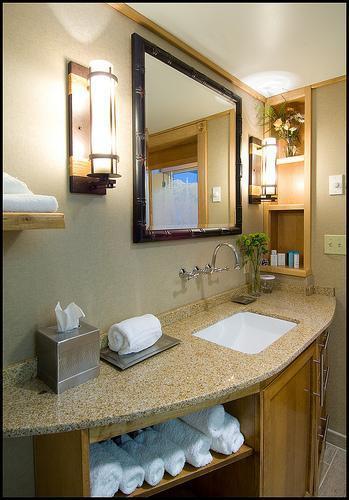How many plants are in the bathroom?
Give a very brief answer. 2. How many lights are in the picture?
Give a very brief answer. 2. How many towels are in the picture?
Give a very brief answer. 10. 